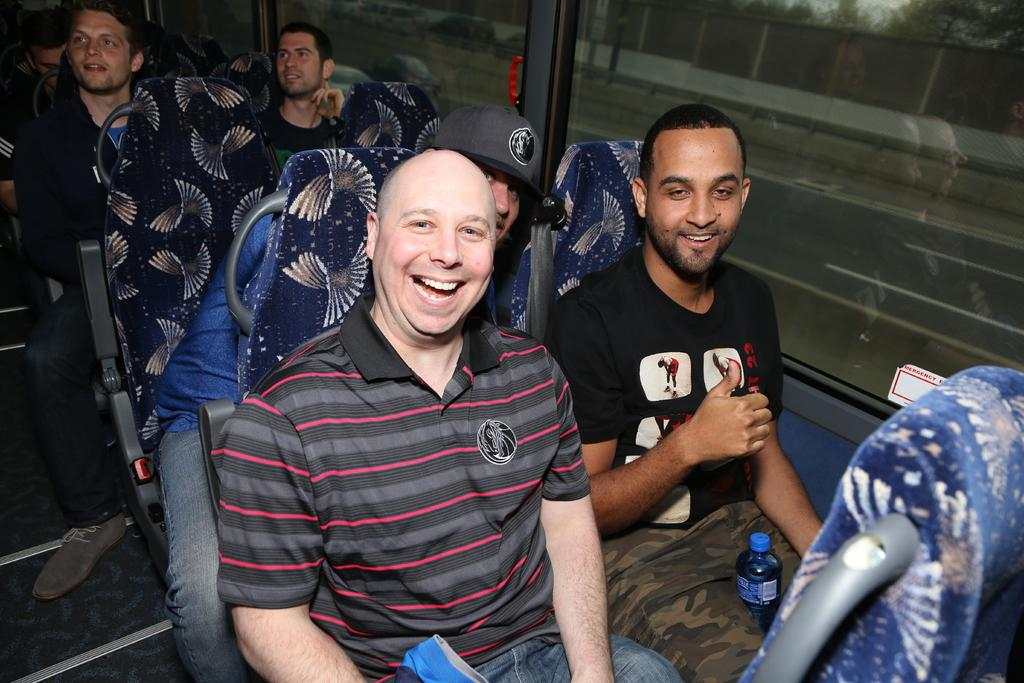What is happening in the image? There is a group of people in the image, and they appear to be sitting in a bus. Can you describe the person in the center of the image? The person in the center of the image is laughing. Where is the queen sitting in the image? There is no queen present in the image. Can you tell me how many books are on the shelf in the image? There is no shelf present in the image. 